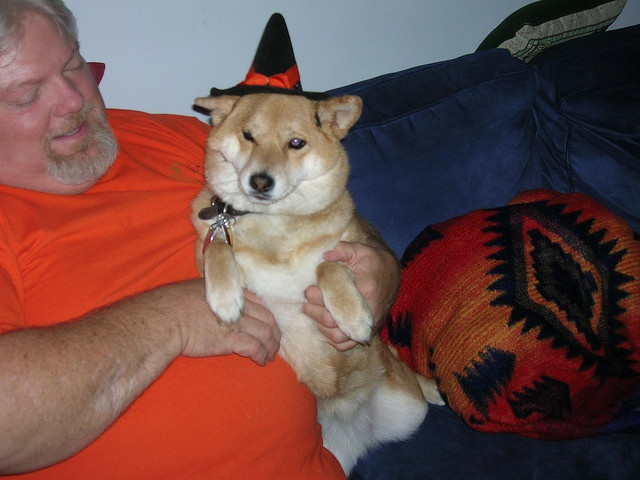Describe the objects in this image and their specific colors. I can see people in gray, red, and brown tones, couch in gray, black, navy, and maroon tones, and dog in gray, darkgray, and tan tones in this image. 